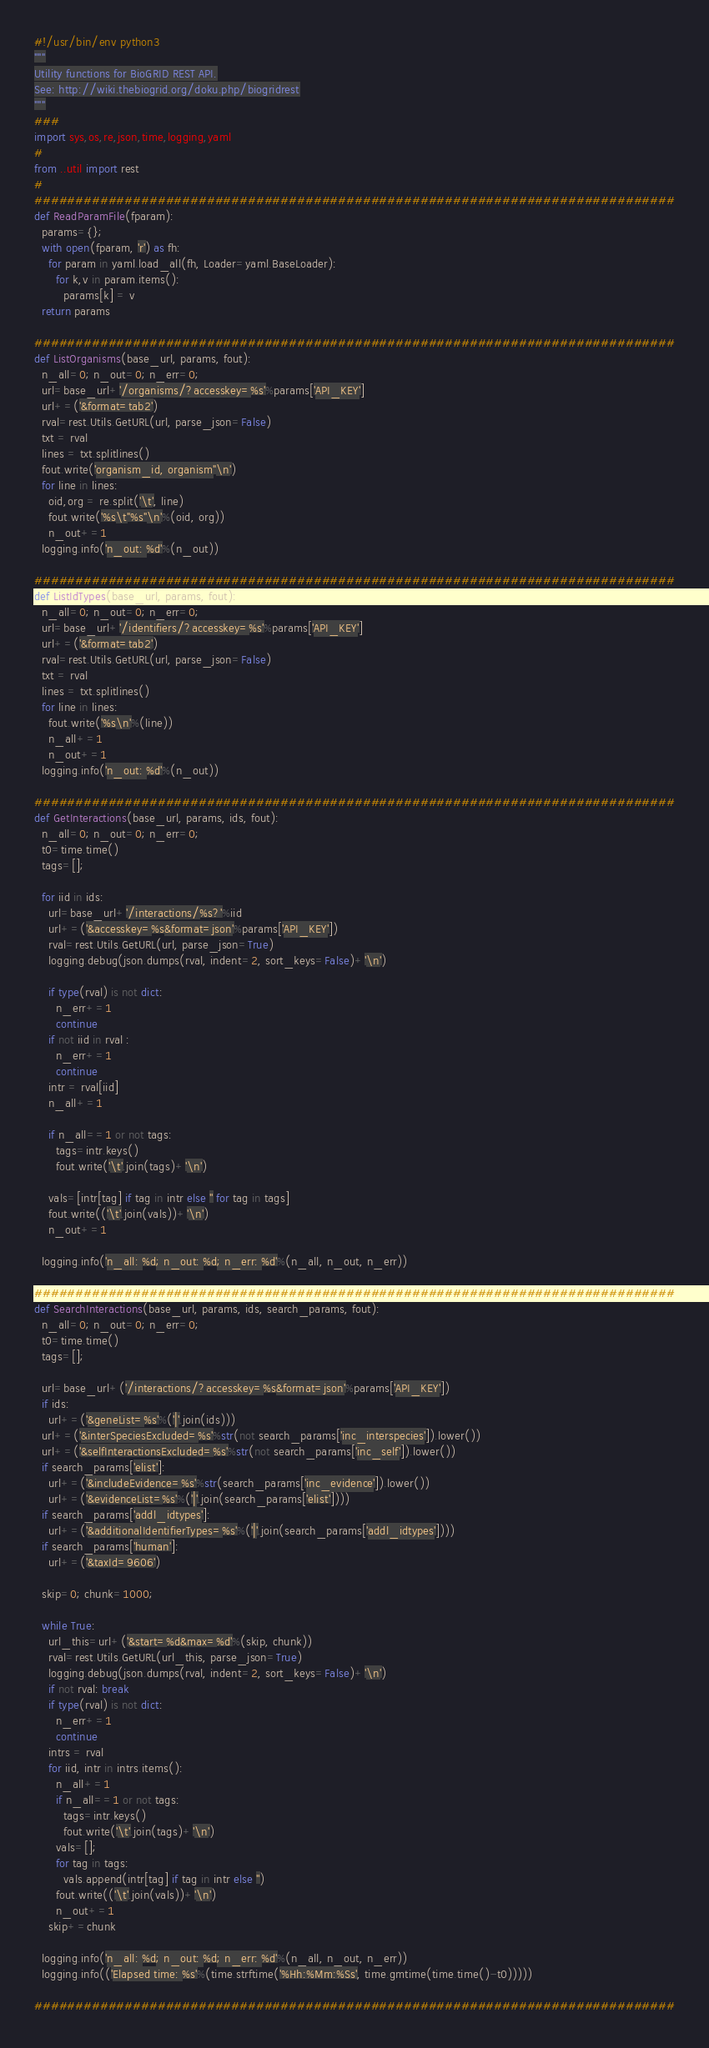Convert code to text. <code><loc_0><loc_0><loc_500><loc_500><_Python_>#!/usr/bin/env python3
"""
Utility functions for BioGRID REST API.
See: http://wiki.thebiogrid.org/doku.php/biogridrest
"""
###
import sys,os,re,json,time,logging,yaml
#
from ..util import rest
#
##############################################################################
def ReadParamFile(fparam):
  params={};
  with open(fparam, 'r') as fh:
    for param in yaml.load_all(fh, Loader=yaml.BaseLoader):
      for k,v in param.items():
        params[k] = v
  return params

##############################################################################
def ListOrganisms(base_url, params, fout):
  n_all=0; n_out=0; n_err=0;
  url=base_url+'/organisms/?accesskey=%s'%params['API_KEY']
  url+=('&format=tab2')
  rval=rest.Utils.GetURL(url, parse_json=False)
  txt = rval
  lines = txt.splitlines()
  fout.write('organism_id, organism"\n')
  for line in lines:
    oid,org = re.split('\t', line)
    fout.write('%s\t"%s"\n'%(oid, org))
    n_out+=1
  logging.info('n_out: %d'%(n_out))

##############################################################################
def ListIdTypes(base_url, params, fout):
  n_all=0; n_out=0; n_err=0;
  url=base_url+'/identifiers/?accesskey=%s'%params['API_KEY']
  url+=('&format=tab2')
  rval=rest.Utils.GetURL(url, parse_json=False)
  txt = rval
  lines = txt.splitlines()
  for line in lines:
    fout.write('%s\n'%(line))
    n_all+=1
    n_out+=1
  logging.info('n_out: %d'%(n_out))

##############################################################################
def GetInteractions(base_url, params, ids, fout):
  n_all=0; n_out=0; n_err=0;
  t0=time.time()
  tags=[];

  for iid in ids:
    url=base_url+'/interactions/%s?'%iid
    url+=('&accesskey=%s&format=json'%params['API_KEY'])
    rval=rest.Utils.GetURL(url, parse_json=True)
    logging.debug(json.dumps(rval, indent=2, sort_keys=False)+'\n')

    if type(rval) is not dict:
      n_err+=1
      continue
    if not iid in rval :
      n_err+=1
      continue
    intr = rval[iid]
    n_all+=1

    if n_all==1 or not tags:
      tags=intr.keys()
      fout.write('\t'.join(tags)+'\n')

    vals=[intr[tag] if tag in intr else '' for tag in tags]
    fout.write(('\t'.join(vals))+'\n')
    n_out+=1

  logging.info('n_all: %d; n_out: %d; n_err: %d'%(n_all, n_out, n_err))

##############################################################################
def SearchInteractions(base_url, params, ids, search_params, fout):
  n_all=0; n_out=0; n_err=0;
  t0=time.time()
  tags=[];

  url=base_url+('/interactions/?accesskey=%s&format=json'%params['API_KEY'])
  if ids:
    url+=('&geneList=%s'%('|'.join(ids)))
  url+=('&interSpeciesExcluded=%s'%str(not search_params['inc_interspecies']).lower())
  url+=('&selfInteractionsExcluded=%s'%str(not search_params['inc_self']).lower())
  if search_params['elist']:
    url+=('&includeEvidence=%s'%str(search_params['inc_evidence']).lower())
    url+=('&evidenceList=%s'%('|'.join(search_params['elist'])))
  if search_params['addl_idtypes']:
    url+=('&additionalIdentifierTypes=%s'%('|'.join(search_params['addl_idtypes'])))
  if search_params['human']:
    url+=('&taxId=9606')

  skip=0; chunk=1000;

  while True:
    url_this=url+('&start=%d&max=%d'%(skip, chunk))
    rval=rest.Utils.GetURL(url_this, parse_json=True)
    logging.debug(json.dumps(rval, indent=2, sort_keys=False)+'\n')
    if not rval: break
    if type(rval) is not dict:
      n_err+=1
      continue
    intrs = rval
    for iid, intr in intrs.items():
      n_all+=1
      if n_all==1 or not tags:
        tags=intr.keys()
        fout.write('\t'.join(tags)+'\n')
      vals=[];
      for tag in tags:
        vals.append(intr[tag] if tag in intr else '')
      fout.write(('\t'.join(vals))+'\n')
      n_out+=1
    skip+=chunk

  logging.info('n_all: %d; n_out: %d; n_err: %d'%(n_all, n_out, n_err))
  logging.info(('Elapsed time: %s'%(time.strftime('%Hh:%Mm:%Ss', time.gmtime(time.time()-t0)))))

##############################################################################
</code> 